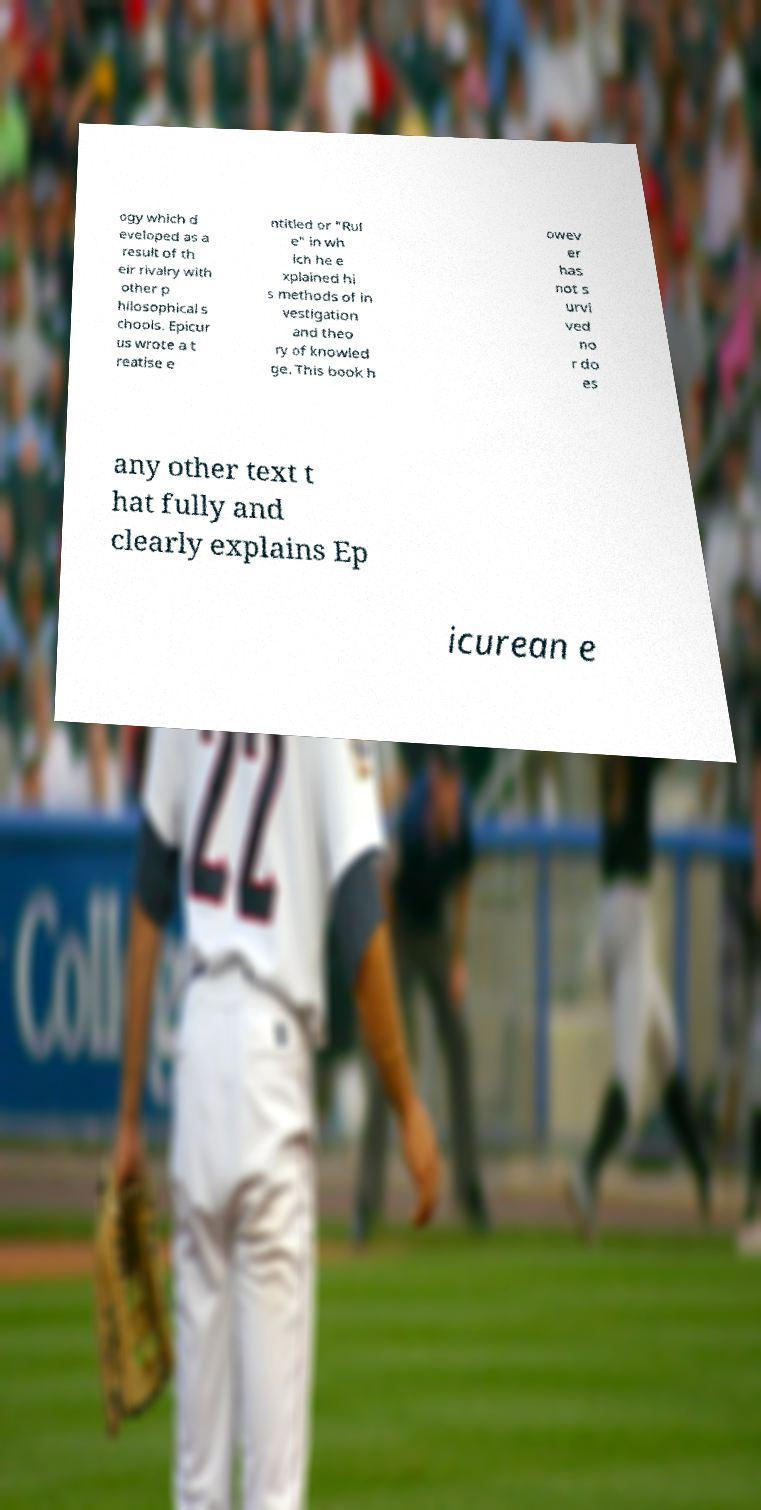Can you read and provide the text displayed in the image?This photo seems to have some interesting text. Can you extract and type it out for me? ogy which d eveloped as a result of th eir rivalry with other p hilosophical s chools. Epicur us wrote a t reatise e ntitled or "Rul e" in wh ich he e xplained hi s methods of in vestigation and theo ry of knowled ge. This book h owev er has not s urvi ved no r do es any other text t hat fully and clearly explains Ep icurean e 